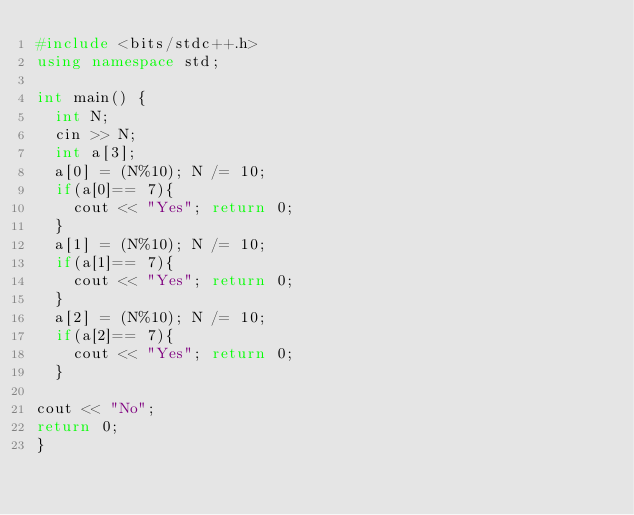<code> <loc_0><loc_0><loc_500><loc_500><_C++_>#include <bits/stdc++.h>
using namespace std;

int main() {
  int N;
  cin >> N;
  int a[3];
  a[0] = (N%10); N /= 10;
  if(a[0]== 7){
    cout << "Yes"; return 0;
  }
  a[1] = (N%10); N /= 10;
  if(a[1]== 7){
    cout << "Yes"; return 0;
  }
  a[2] = (N%10); N /= 10;
  if(a[2]== 7){
    cout << "Yes"; return 0;
  }

cout << "No";
return 0;
}</code> 